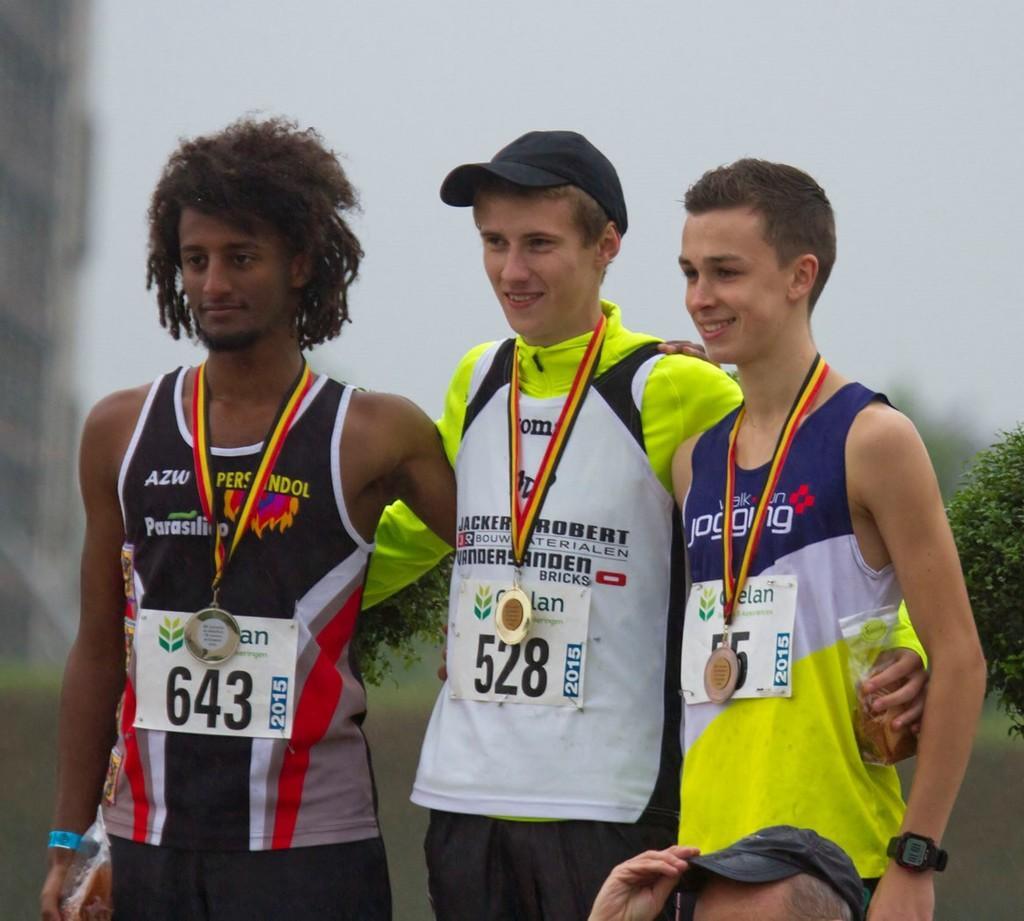In one or two sentences, can you explain what this image depicts? In this image I can see three men are standing and I can see all of them are wearing sports wear and around their neck I can see medals. On their dresses I can see few papers and on it I can see something is written. In the background I can see few plants. 